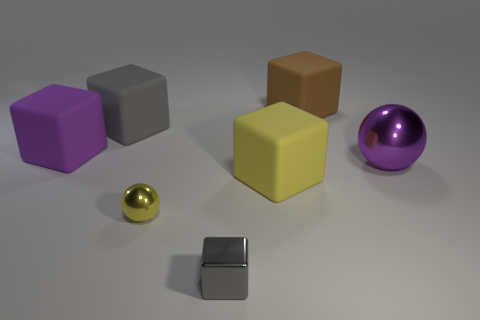There is a shiny object on the right side of the gray shiny block; is its size the same as the big yellow cube?
Your answer should be compact. Yes. How many gray rubber things are the same shape as the gray metallic thing?
Offer a terse response. 1. The large purple shiny thing is what shape?
Make the answer very short. Sphere. Is the number of yellow metallic balls behind the large yellow matte thing the same as the number of big yellow matte cubes?
Keep it short and to the point. No. Do the large purple thing that is to the left of the gray matte object and the large brown thing have the same material?
Provide a short and direct response. Yes. Are there fewer metallic objects that are to the left of the small yellow shiny object than yellow matte things?
Ensure brevity in your answer.  Yes. How many rubber objects are either big purple things or small yellow objects?
Your response must be concise. 1. Is the large ball the same color as the tiny metallic ball?
Your response must be concise. No. There is a matte thing in front of the purple matte thing; is its shape the same as the purple object right of the big gray block?
Offer a very short reply. No. What number of objects are tiny cyan matte things or rubber blocks on the right side of the gray matte cube?
Your response must be concise. 2. 